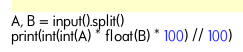Convert code to text. <code><loc_0><loc_0><loc_500><loc_500><_Python_>A, B = input().split()
print(int(int(A) * float(B) * 100) // 100)
</code> 